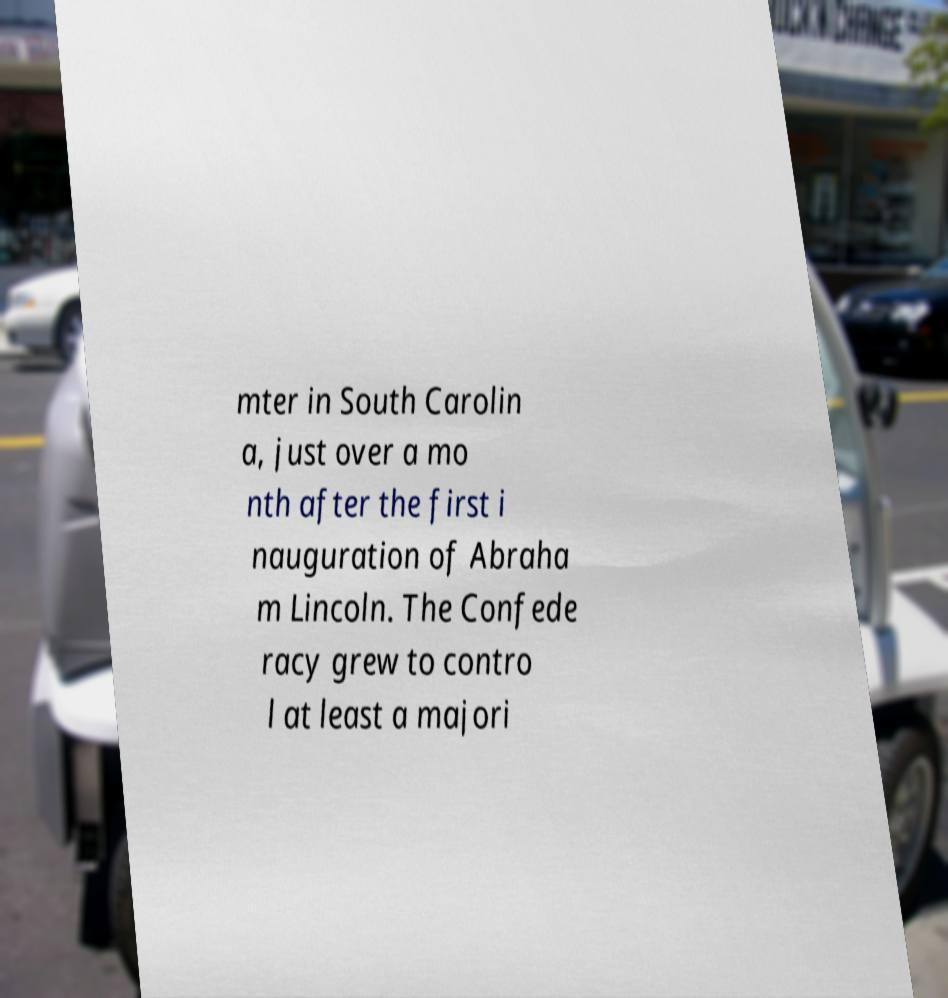Could you extract and type out the text from this image? mter in South Carolin a, just over a mo nth after the first i nauguration of Abraha m Lincoln. The Confede racy grew to contro l at least a majori 